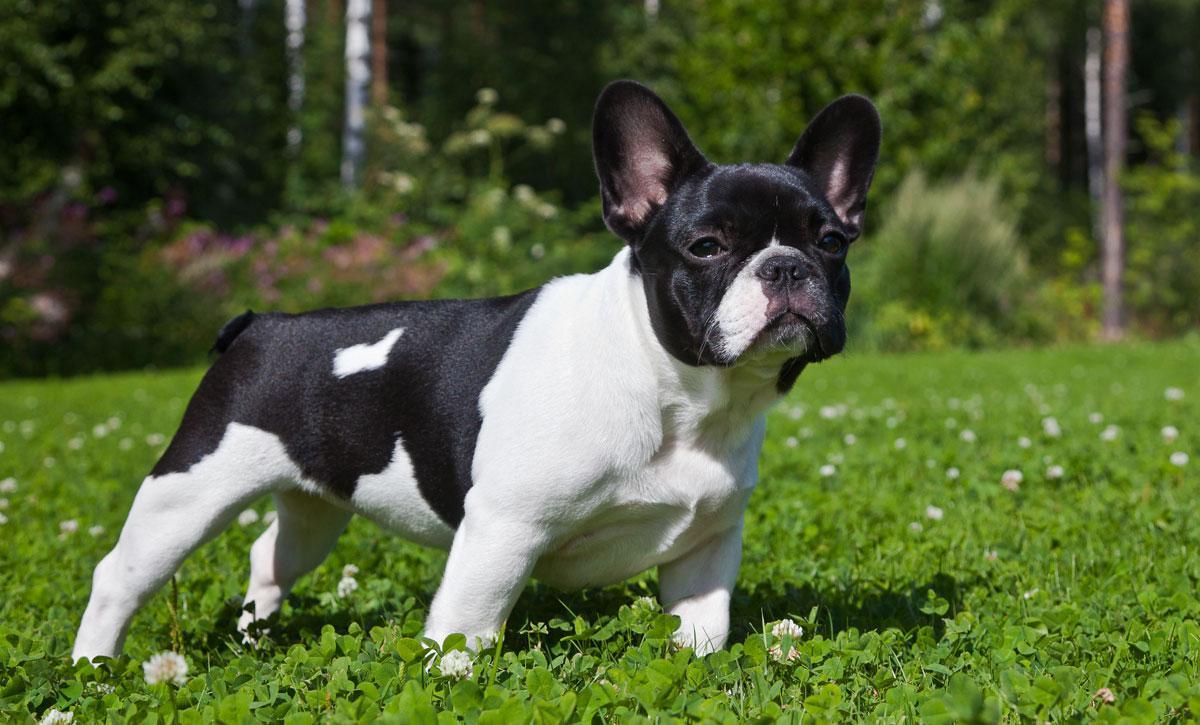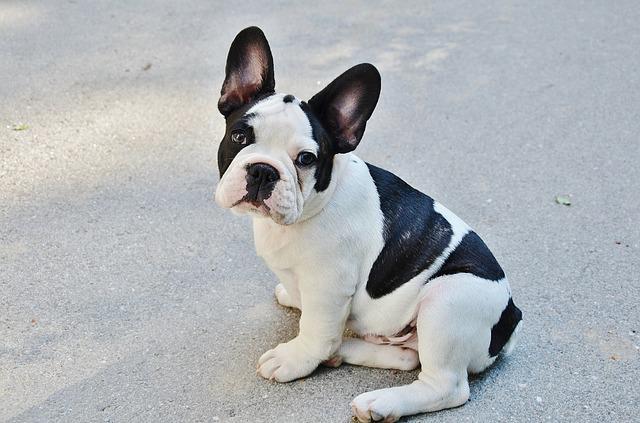The first image is the image on the left, the second image is the image on the right. For the images displayed, is the sentence "Each image shows one sitting dog with black-and-white coloring, at least on its face." factually correct? Answer yes or no. No. 